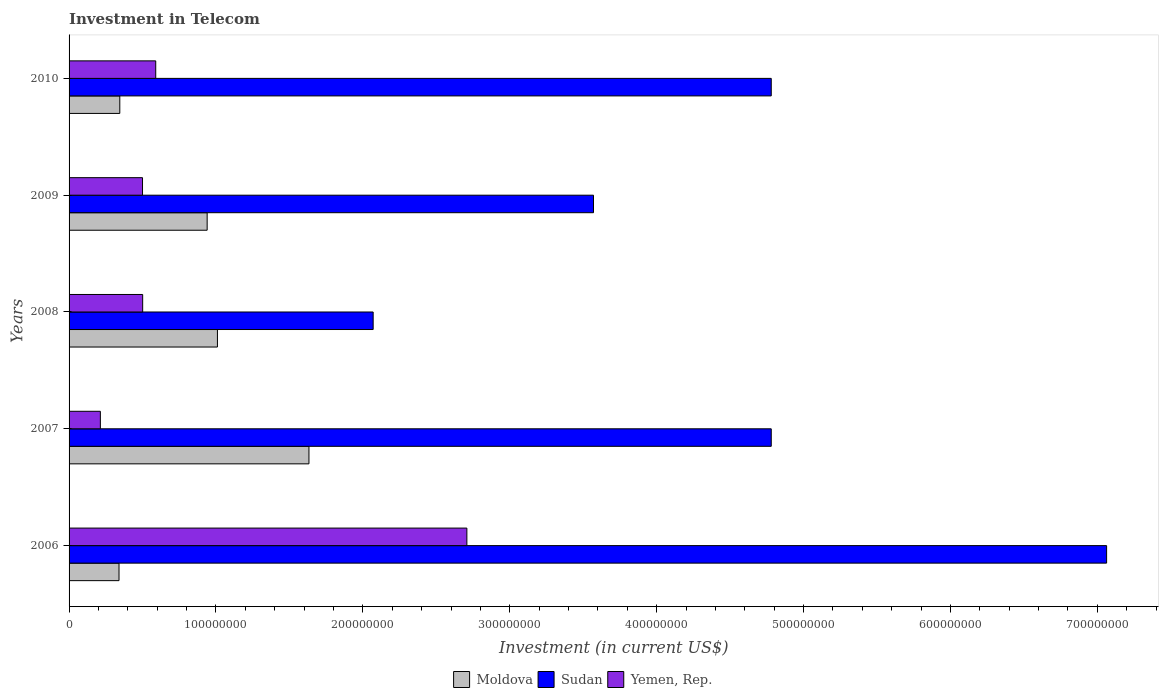How many different coloured bars are there?
Offer a very short reply. 3. How many groups of bars are there?
Provide a short and direct response. 5. Are the number of bars on each tick of the Y-axis equal?
Your response must be concise. Yes. How many bars are there on the 4th tick from the bottom?
Offer a terse response. 3. What is the label of the 1st group of bars from the top?
Your answer should be very brief. 2010. In how many cases, is the number of bars for a given year not equal to the number of legend labels?
Offer a terse response. 0. What is the amount invested in telecom in Moldova in 2009?
Make the answer very short. 9.40e+07. Across all years, what is the maximum amount invested in telecom in Yemen, Rep.?
Ensure brevity in your answer.  2.71e+08. Across all years, what is the minimum amount invested in telecom in Yemen, Rep.?
Keep it short and to the point. 2.13e+07. In which year was the amount invested in telecom in Sudan minimum?
Your answer should be compact. 2008. What is the total amount invested in telecom in Yemen, Rep. in the graph?
Make the answer very short. 4.51e+08. What is the difference between the amount invested in telecom in Yemen, Rep. in 2008 and that in 2010?
Your answer should be very brief. -8.90e+06. What is the difference between the amount invested in telecom in Sudan in 2009 and the amount invested in telecom in Moldova in 2007?
Provide a short and direct response. 1.94e+08. What is the average amount invested in telecom in Yemen, Rep. per year?
Your response must be concise. 9.02e+07. In the year 2008, what is the difference between the amount invested in telecom in Moldova and amount invested in telecom in Yemen, Rep.?
Provide a short and direct response. 5.09e+07. In how many years, is the amount invested in telecom in Moldova greater than 500000000 US$?
Your answer should be very brief. 0. What is the ratio of the amount invested in telecom in Moldova in 2006 to that in 2008?
Keep it short and to the point. 0.34. Is the amount invested in telecom in Sudan in 2007 less than that in 2009?
Keep it short and to the point. No. What is the difference between the highest and the second highest amount invested in telecom in Moldova?
Offer a terse response. 6.23e+07. What is the difference between the highest and the lowest amount invested in telecom in Moldova?
Your answer should be very brief. 1.29e+08. Is the sum of the amount invested in telecom in Yemen, Rep. in 2007 and 2010 greater than the maximum amount invested in telecom in Sudan across all years?
Your answer should be compact. No. What does the 2nd bar from the top in 2007 represents?
Make the answer very short. Sudan. What does the 1st bar from the bottom in 2007 represents?
Provide a succinct answer. Moldova. Is it the case that in every year, the sum of the amount invested in telecom in Sudan and amount invested in telecom in Yemen, Rep. is greater than the amount invested in telecom in Moldova?
Ensure brevity in your answer.  Yes. How many bars are there?
Make the answer very short. 15. What is the difference between two consecutive major ticks on the X-axis?
Offer a terse response. 1.00e+08. Are the values on the major ticks of X-axis written in scientific E-notation?
Offer a terse response. No. Does the graph contain any zero values?
Your answer should be compact. No. Does the graph contain grids?
Your response must be concise. No. What is the title of the graph?
Give a very brief answer. Investment in Telecom. What is the label or title of the X-axis?
Your response must be concise. Investment (in current US$). What is the Investment (in current US$) in Moldova in 2006?
Offer a terse response. 3.40e+07. What is the Investment (in current US$) of Sudan in 2006?
Ensure brevity in your answer.  7.06e+08. What is the Investment (in current US$) of Yemen, Rep. in 2006?
Offer a very short reply. 2.71e+08. What is the Investment (in current US$) of Moldova in 2007?
Your response must be concise. 1.63e+08. What is the Investment (in current US$) of Sudan in 2007?
Ensure brevity in your answer.  4.78e+08. What is the Investment (in current US$) in Yemen, Rep. in 2007?
Offer a very short reply. 2.13e+07. What is the Investment (in current US$) in Moldova in 2008?
Give a very brief answer. 1.01e+08. What is the Investment (in current US$) in Sudan in 2008?
Your answer should be very brief. 2.07e+08. What is the Investment (in current US$) in Yemen, Rep. in 2008?
Make the answer very short. 5.01e+07. What is the Investment (in current US$) of Moldova in 2009?
Provide a succinct answer. 9.40e+07. What is the Investment (in current US$) in Sudan in 2009?
Keep it short and to the point. 3.57e+08. What is the Investment (in current US$) of Moldova in 2010?
Your response must be concise. 3.45e+07. What is the Investment (in current US$) in Sudan in 2010?
Offer a terse response. 4.78e+08. What is the Investment (in current US$) of Yemen, Rep. in 2010?
Keep it short and to the point. 5.90e+07. Across all years, what is the maximum Investment (in current US$) of Moldova?
Offer a very short reply. 1.63e+08. Across all years, what is the maximum Investment (in current US$) of Sudan?
Offer a terse response. 7.06e+08. Across all years, what is the maximum Investment (in current US$) in Yemen, Rep.?
Your response must be concise. 2.71e+08. Across all years, what is the minimum Investment (in current US$) of Moldova?
Your answer should be compact. 3.40e+07. Across all years, what is the minimum Investment (in current US$) of Sudan?
Offer a very short reply. 2.07e+08. Across all years, what is the minimum Investment (in current US$) in Yemen, Rep.?
Keep it short and to the point. 2.13e+07. What is the total Investment (in current US$) in Moldova in the graph?
Give a very brief answer. 4.27e+08. What is the total Investment (in current US$) of Sudan in the graph?
Offer a terse response. 2.23e+09. What is the total Investment (in current US$) of Yemen, Rep. in the graph?
Provide a short and direct response. 4.51e+08. What is the difference between the Investment (in current US$) in Moldova in 2006 and that in 2007?
Your answer should be compact. -1.29e+08. What is the difference between the Investment (in current US$) in Sudan in 2006 and that in 2007?
Give a very brief answer. 2.28e+08. What is the difference between the Investment (in current US$) in Yemen, Rep. in 2006 and that in 2007?
Make the answer very short. 2.50e+08. What is the difference between the Investment (in current US$) of Moldova in 2006 and that in 2008?
Provide a succinct answer. -6.70e+07. What is the difference between the Investment (in current US$) of Sudan in 2006 and that in 2008?
Your answer should be very brief. 4.99e+08. What is the difference between the Investment (in current US$) in Yemen, Rep. in 2006 and that in 2008?
Keep it short and to the point. 2.21e+08. What is the difference between the Investment (in current US$) in Moldova in 2006 and that in 2009?
Your answer should be compact. -6.00e+07. What is the difference between the Investment (in current US$) in Sudan in 2006 and that in 2009?
Provide a succinct answer. 3.49e+08. What is the difference between the Investment (in current US$) of Yemen, Rep. in 2006 and that in 2009?
Ensure brevity in your answer.  2.21e+08. What is the difference between the Investment (in current US$) in Moldova in 2006 and that in 2010?
Give a very brief answer. -5.30e+05. What is the difference between the Investment (in current US$) in Sudan in 2006 and that in 2010?
Give a very brief answer. 2.28e+08. What is the difference between the Investment (in current US$) in Yemen, Rep. in 2006 and that in 2010?
Give a very brief answer. 2.12e+08. What is the difference between the Investment (in current US$) in Moldova in 2007 and that in 2008?
Offer a very short reply. 6.23e+07. What is the difference between the Investment (in current US$) in Sudan in 2007 and that in 2008?
Offer a terse response. 2.71e+08. What is the difference between the Investment (in current US$) of Yemen, Rep. in 2007 and that in 2008?
Your answer should be very brief. -2.88e+07. What is the difference between the Investment (in current US$) in Moldova in 2007 and that in 2009?
Provide a succinct answer. 6.93e+07. What is the difference between the Investment (in current US$) in Sudan in 2007 and that in 2009?
Your response must be concise. 1.21e+08. What is the difference between the Investment (in current US$) in Yemen, Rep. in 2007 and that in 2009?
Give a very brief answer. -2.87e+07. What is the difference between the Investment (in current US$) in Moldova in 2007 and that in 2010?
Make the answer very short. 1.29e+08. What is the difference between the Investment (in current US$) in Sudan in 2007 and that in 2010?
Keep it short and to the point. 0. What is the difference between the Investment (in current US$) in Yemen, Rep. in 2007 and that in 2010?
Offer a very short reply. -3.77e+07. What is the difference between the Investment (in current US$) in Moldova in 2008 and that in 2009?
Your answer should be very brief. 7.00e+06. What is the difference between the Investment (in current US$) in Sudan in 2008 and that in 2009?
Your answer should be compact. -1.50e+08. What is the difference between the Investment (in current US$) of Moldova in 2008 and that in 2010?
Offer a very short reply. 6.65e+07. What is the difference between the Investment (in current US$) of Sudan in 2008 and that in 2010?
Provide a short and direct response. -2.71e+08. What is the difference between the Investment (in current US$) of Yemen, Rep. in 2008 and that in 2010?
Provide a short and direct response. -8.90e+06. What is the difference between the Investment (in current US$) of Moldova in 2009 and that in 2010?
Provide a succinct answer. 5.95e+07. What is the difference between the Investment (in current US$) of Sudan in 2009 and that in 2010?
Ensure brevity in your answer.  -1.21e+08. What is the difference between the Investment (in current US$) in Yemen, Rep. in 2009 and that in 2010?
Keep it short and to the point. -9.00e+06. What is the difference between the Investment (in current US$) of Moldova in 2006 and the Investment (in current US$) of Sudan in 2007?
Your response must be concise. -4.44e+08. What is the difference between the Investment (in current US$) of Moldova in 2006 and the Investment (in current US$) of Yemen, Rep. in 2007?
Ensure brevity in your answer.  1.27e+07. What is the difference between the Investment (in current US$) of Sudan in 2006 and the Investment (in current US$) of Yemen, Rep. in 2007?
Give a very brief answer. 6.85e+08. What is the difference between the Investment (in current US$) in Moldova in 2006 and the Investment (in current US$) in Sudan in 2008?
Offer a very short reply. -1.73e+08. What is the difference between the Investment (in current US$) of Moldova in 2006 and the Investment (in current US$) of Yemen, Rep. in 2008?
Offer a very short reply. -1.61e+07. What is the difference between the Investment (in current US$) in Sudan in 2006 and the Investment (in current US$) in Yemen, Rep. in 2008?
Make the answer very short. 6.56e+08. What is the difference between the Investment (in current US$) in Moldova in 2006 and the Investment (in current US$) in Sudan in 2009?
Keep it short and to the point. -3.23e+08. What is the difference between the Investment (in current US$) of Moldova in 2006 and the Investment (in current US$) of Yemen, Rep. in 2009?
Your answer should be compact. -1.60e+07. What is the difference between the Investment (in current US$) of Sudan in 2006 and the Investment (in current US$) of Yemen, Rep. in 2009?
Offer a very short reply. 6.56e+08. What is the difference between the Investment (in current US$) of Moldova in 2006 and the Investment (in current US$) of Sudan in 2010?
Your answer should be very brief. -4.44e+08. What is the difference between the Investment (in current US$) in Moldova in 2006 and the Investment (in current US$) in Yemen, Rep. in 2010?
Offer a terse response. -2.50e+07. What is the difference between the Investment (in current US$) of Sudan in 2006 and the Investment (in current US$) of Yemen, Rep. in 2010?
Your answer should be very brief. 6.47e+08. What is the difference between the Investment (in current US$) in Moldova in 2007 and the Investment (in current US$) in Sudan in 2008?
Provide a short and direct response. -4.37e+07. What is the difference between the Investment (in current US$) in Moldova in 2007 and the Investment (in current US$) in Yemen, Rep. in 2008?
Provide a succinct answer. 1.13e+08. What is the difference between the Investment (in current US$) in Sudan in 2007 and the Investment (in current US$) in Yemen, Rep. in 2008?
Provide a short and direct response. 4.28e+08. What is the difference between the Investment (in current US$) of Moldova in 2007 and the Investment (in current US$) of Sudan in 2009?
Ensure brevity in your answer.  -1.94e+08. What is the difference between the Investment (in current US$) in Moldova in 2007 and the Investment (in current US$) in Yemen, Rep. in 2009?
Your answer should be compact. 1.13e+08. What is the difference between the Investment (in current US$) of Sudan in 2007 and the Investment (in current US$) of Yemen, Rep. in 2009?
Provide a short and direct response. 4.28e+08. What is the difference between the Investment (in current US$) in Moldova in 2007 and the Investment (in current US$) in Sudan in 2010?
Ensure brevity in your answer.  -3.15e+08. What is the difference between the Investment (in current US$) of Moldova in 2007 and the Investment (in current US$) of Yemen, Rep. in 2010?
Offer a terse response. 1.04e+08. What is the difference between the Investment (in current US$) in Sudan in 2007 and the Investment (in current US$) in Yemen, Rep. in 2010?
Ensure brevity in your answer.  4.19e+08. What is the difference between the Investment (in current US$) in Moldova in 2008 and the Investment (in current US$) in Sudan in 2009?
Make the answer very short. -2.56e+08. What is the difference between the Investment (in current US$) of Moldova in 2008 and the Investment (in current US$) of Yemen, Rep. in 2009?
Provide a succinct answer. 5.10e+07. What is the difference between the Investment (in current US$) in Sudan in 2008 and the Investment (in current US$) in Yemen, Rep. in 2009?
Give a very brief answer. 1.57e+08. What is the difference between the Investment (in current US$) in Moldova in 2008 and the Investment (in current US$) in Sudan in 2010?
Your response must be concise. -3.77e+08. What is the difference between the Investment (in current US$) of Moldova in 2008 and the Investment (in current US$) of Yemen, Rep. in 2010?
Make the answer very short. 4.20e+07. What is the difference between the Investment (in current US$) of Sudan in 2008 and the Investment (in current US$) of Yemen, Rep. in 2010?
Your response must be concise. 1.48e+08. What is the difference between the Investment (in current US$) in Moldova in 2009 and the Investment (in current US$) in Sudan in 2010?
Make the answer very short. -3.84e+08. What is the difference between the Investment (in current US$) in Moldova in 2009 and the Investment (in current US$) in Yemen, Rep. in 2010?
Ensure brevity in your answer.  3.50e+07. What is the difference between the Investment (in current US$) in Sudan in 2009 and the Investment (in current US$) in Yemen, Rep. in 2010?
Ensure brevity in your answer.  2.98e+08. What is the average Investment (in current US$) of Moldova per year?
Offer a very short reply. 8.54e+07. What is the average Investment (in current US$) of Sudan per year?
Offer a terse response. 4.45e+08. What is the average Investment (in current US$) of Yemen, Rep. per year?
Ensure brevity in your answer.  9.02e+07. In the year 2006, what is the difference between the Investment (in current US$) of Moldova and Investment (in current US$) of Sudan?
Your answer should be compact. -6.72e+08. In the year 2006, what is the difference between the Investment (in current US$) in Moldova and Investment (in current US$) in Yemen, Rep.?
Ensure brevity in your answer.  -2.37e+08. In the year 2006, what is the difference between the Investment (in current US$) of Sudan and Investment (in current US$) of Yemen, Rep.?
Ensure brevity in your answer.  4.36e+08. In the year 2007, what is the difference between the Investment (in current US$) in Moldova and Investment (in current US$) in Sudan?
Make the answer very short. -3.15e+08. In the year 2007, what is the difference between the Investment (in current US$) in Moldova and Investment (in current US$) in Yemen, Rep.?
Keep it short and to the point. 1.42e+08. In the year 2007, what is the difference between the Investment (in current US$) in Sudan and Investment (in current US$) in Yemen, Rep.?
Your answer should be compact. 4.57e+08. In the year 2008, what is the difference between the Investment (in current US$) in Moldova and Investment (in current US$) in Sudan?
Provide a succinct answer. -1.06e+08. In the year 2008, what is the difference between the Investment (in current US$) in Moldova and Investment (in current US$) in Yemen, Rep.?
Make the answer very short. 5.09e+07. In the year 2008, what is the difference between the Investment (in current US$) in Sudan and Investment (in current US$) in Yemen, Rep.?
Keep it short and to the point. 1.57e+08. In the year 2009, what is the difference between the Investment (in current US$) in Moldova and Investment (in current US$) in Sudan?
Make the answer very short. -2.63e+08. In the year 2009, what is the difference between the Investment (in current US$) of Moldova and Investment (in current US$) of Yemen, Rep.?
Your response must be concise. 4.40e+07. In the year 2009, what is the difference between the Investment (in current US$) of Sudan and Investment (in current US$) of Yemen, Rep.?
Your answer should be compact. 3.07e+08. In the year 2010, what is the difference between the Investment (in current US$) of Moldova and Investment (in current US$) of Sudan?
Make the answer very short. -4.43e+08. In the year 2010, what is the difference between the Investment (in current US$) of Moldova and Investment (in current US$) of Yemen, Rep.?
Ensure brevity in your answer.  -2.45e+07. In the year 2010, what is the difference between the Investment (in current US$) of Sudan and Investment (in current US$) of Yemen, Rep.?
Provide a short and direct response. 4.19e+08. What is the ratio of the Investment (in current US$) in Moldova in 2006 to that in 2007?
Your answer should be very brief. 0.21. What is the ratio of the Investment (in current US$) of Sudan in 2006 to that in 2007?
Provide a succinct answer. 1.48. What is the ratio of the Investment (in current US$) in Yemen, Rep. in 2006 to that in 2007?
Offer a terse response. 12.71. What is the ratio of the Investment (in current US$) of Moldova in 2006 to that in 2008?
Your answer should be very brief. 0.34. What is the ratio of the Investment (in current US$) in Sudan in 2006 to that in 2008?
Offer a very short reply. 3.41. What is the ratio of the Investment (in current US$) of Yemen, Rep. in 2006 to that in 2008?
Ensure brevity in your answer.  5.41. What is the ratio of the Investment (in current US$) of Moldova in 2006 to that in 2009?
Make the answer very short. 0.36. What is the ratio of the Investment (in current US$) of Sudan in 2006 to that in 2009?
Provide a succinct answer. 1.98. What is the ratio of the Investment (in current US$) of Yemen, Rep. in 2006 to that in 2009?
Provide a succinct answer. 5.42. What is the ratio of the Investment (in current US$) of Moldova in 2006 to that in 2010?
Your answer should be very brief. 0.98. What is the ratio of the Investment (in current US$) in Sudan in 2006 to that in 2010?
Make the answer very short. 1.48. What is the ratio of the Investment (in current US$) of Yemen, Rep. in 2006 to that in 2010?
Make the answer very short. 4.59. What is the ratio of the Investment (in current US$) in Moldova in 2007 to that in 2008?
Your answer should be very brief. 1.62. What is the ratio of the Investment (in current US$) in Sudan in 2007 to that in 2008?
Keep it short and to the point. 2.31. What is the ratio of the Investment (in current US$) in Yemen, Rep. in 2007 to that in 2008?
Ensure brevity in your answer.  0.43. What is the ratio of the Investment (in current US$) of Moldova in 2007 to that in 2009?
Make the answer very short. 1.74. What is the ratio of the Investment (in current US$) of Sudan in 2007 to that in 2009?
Offer a terse response. 1.34. What is the ratio of the Investment (in current US$) in Yemen, Rep. in 2007 to that in 2009?
Provide a short and direct response. 0.43. What is the ratio of the Investment (in current US$) in Moldova in 2007 to that in 2010?
Provide a short and direct response. 4.73. What is the ratio of the Investment (in current US$) of Sudan in 2007 to that in 2010?
Offer a very short reply. 1. What is the ratio of the Investment (in current US$) of Yemen, Rep. in 2007 to that in 2010?
Your answer should be very brief. 0.36. What is the ratio of the Investment (in current US$) in Moldova in 2008 to that in 2009?
Keep it short and to the point. 1.07. What is the ratio of the Investment (in current US$) in Sudan in 2008 to that in 2009?
Keep it short and to the point. 0.58. What is the ratio of the Investment (in current US$) of Yemen, Rep. in 2008 to that in 2009?
Ensure brevity in your answer.  1. What is the ratio of the Investment (in current US$) of Moldova in 2008 to that in 2010?
Ensure brevity in your answer.  2.92. What is the ratio of the Investment (in current US$) of Sudan in 2008 to that in 2010?
Give a very brief answer. 0.43. What is the ratio of the Investment (in current US$) in Yemen, Rep. in 2008 to that in 2010?
Make the answer very short. 0.85. What is the ratio of the Investment (in current US$) in Moldova in 2009 to that in 2010?
Your answer should be compact. 2.72. What is the ratio of the Investment (in current US$) in Sudan in 2009 to that in 2010?
Your response must be concise. 0.75. What is the ratio of the Investment (in current US$) of Yemen, Rep. in 2009 to that in 2010?
Ensure brevity in your answer.  0.85. What is the difference between the highest and the second highest Investment (in current US$) in Moldova?
Offer a very short reply. 6.23e+07. What is the difference between the highest and the second highest Investment (in current US$) in Sudan?
Make the answer very short. 2.28e+08. What is the difference between the highest and the second highest Investment (in current US$) in Yemen, Rep.?
Make the answer very short. 2.12e+08. What is the difference between the highest and the lowest Investment (in current US$) in Moldova?
Offer a very short reply. 1.29e+08. What is the difference between the highest and the lowest Investment (in current US$) in Sudan?
Offer a terse response. 4.99e+08. What is the difference between the highest and the lowest Investment (in current US$) of Yemen, Rep.?
Your response must be concise. 2.50e+08. 